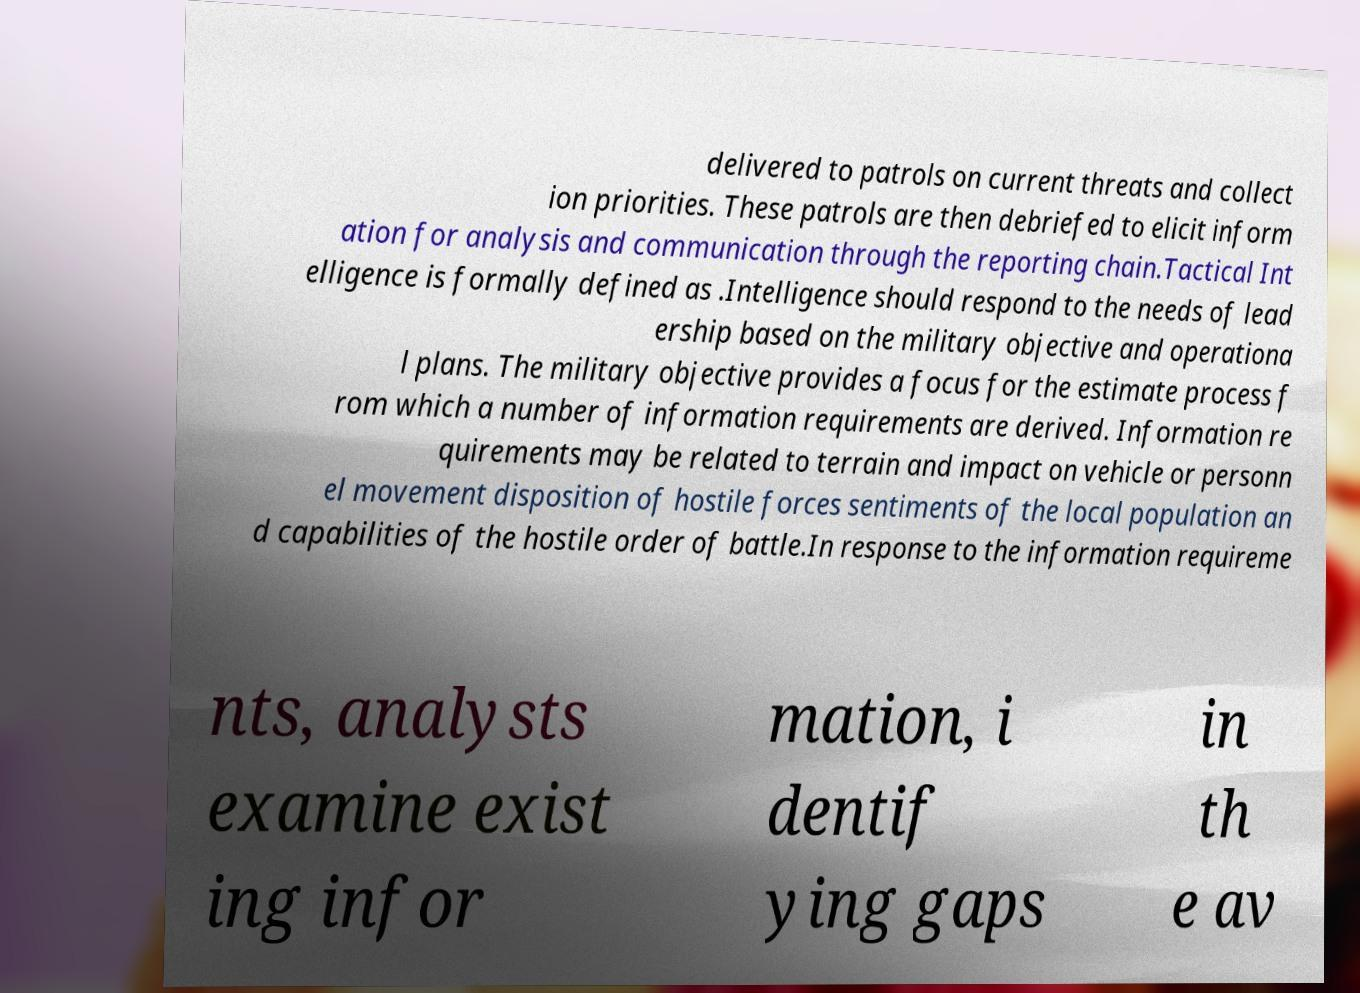I need the written content from this picture converted into text. Can you do that? delivered to patrols on current threats and collect ion priorities. These patrols are then debriefed to elicit inform ation for analysis and communication through the reporting chain.Tactical Int elligence is formally defined as .Intelligence should respond to the needs of lead ership based on the military objective and operationa l plans. The military objective provides a focus for the estimate process f rom which a number of information requirements are derived. Information re quirements may be related to terrain and impact on vehicle or personn el movement disposition of hostile forces sentiments of the local population an d capabilities of the hostile order of battle.In response to the information requireme nts, analysts examine exist ing infor mation, i dentif ying gaps in th e av 